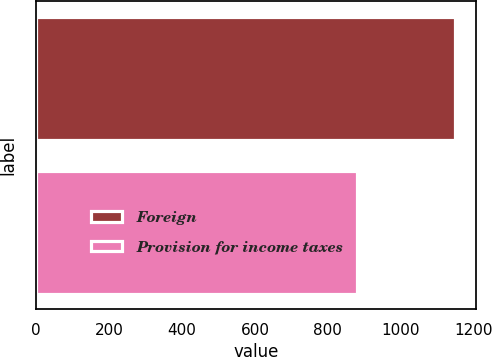Convert chart. <chart><loc_0><loc_0><loc_500><loc_500><bar_chart><fcel>Foreign<fcel>Provision for income taxes<nl><fcel>1149<fcel>880<nl></chart> 